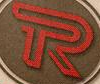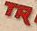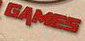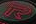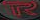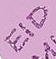Identify the words shown in these images in order, separated by a semicolon. R; TR; GAMES; R; R; EID 